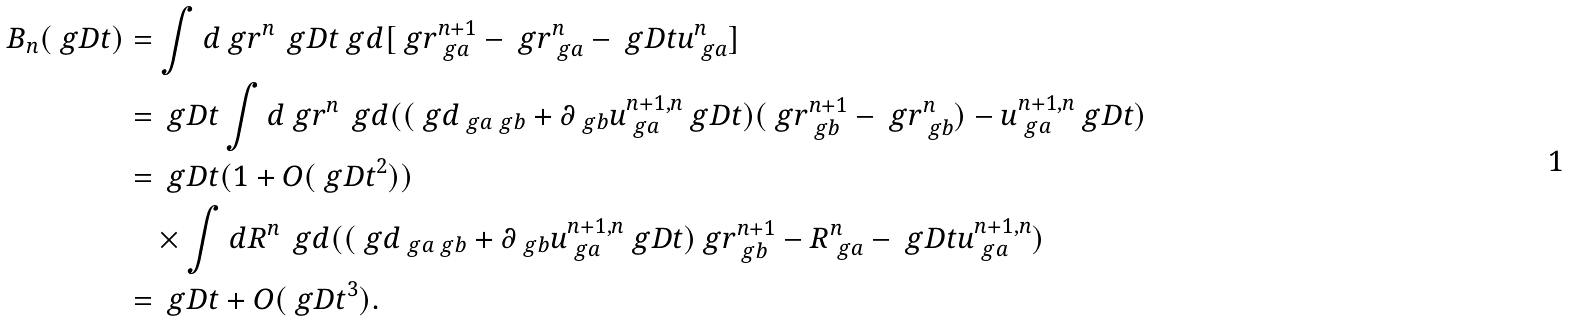<formula> <loc_0><loc_0><loc_500><loc_500>B _ { n } ( \ g D t ) & = \int d \ g r ^ { n } \, \ g D t \ g d [ \ g r _ { \ g a } ^ { n + 1 } - \ g r _ { \ g a } ^ { n } - \ g D t u _ { \ g a } ^ { n } ] \\ & = \ g D t \int d \ g r ^ { n } \, \ g d ( ( \ g d _ { \ g a \ g b } + \partial _ { \ g b } u _ { \ g a } ^ { n + 1 , n } \ g D t ) ( \ g r _ { \ g b } ^ { n + 1 } - \ g r _ { \ g b } ^ { n } ) - u _ { \ g a } ^ { n + 1 , n } \ g D t ) \\ & = \ g D t ( 1 + O ( \ g D t ^ { 2 } ) ) \\ & \quad \times \int d R ^ { n } \, \ g d ( ( \ g d _ { \ g a \ g b } + \partial _ { \ g b } u _ { \ g a } ^ { n + 1 , n } \ g D t ) \ g r _ { \ g b } ^ { n + 1 } - R _ { \ g a } ^ { n } - \ g D t u _ { \ g a } ^ { n + 1 , n } ) \\ & = \ g D t + O ( \ g D t ^ { 3 } ) .</formula> 